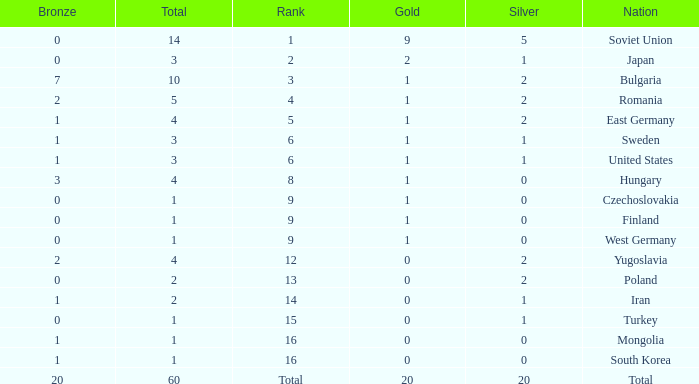What is the sum of golds for ranks of 6 and totals over 3? None. 